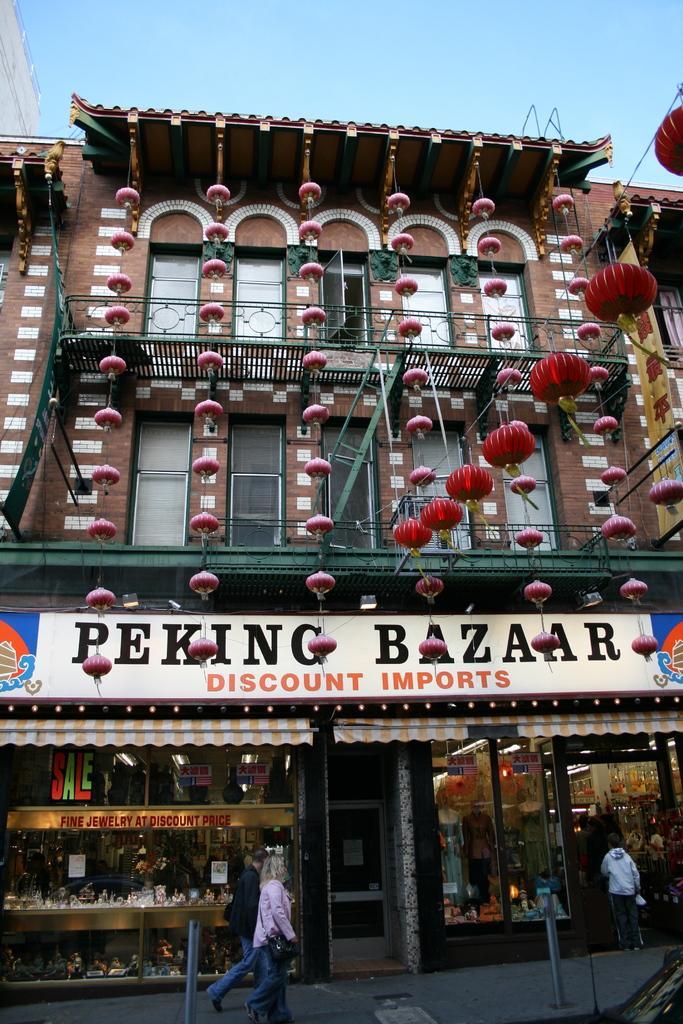Can you describe this image briefly? In this picture we can see a building with windows, glass doors and a name board. In front of the building, there are people and lanterns. At the top of the image, there is the sky. Inside the building, there are some objects. 